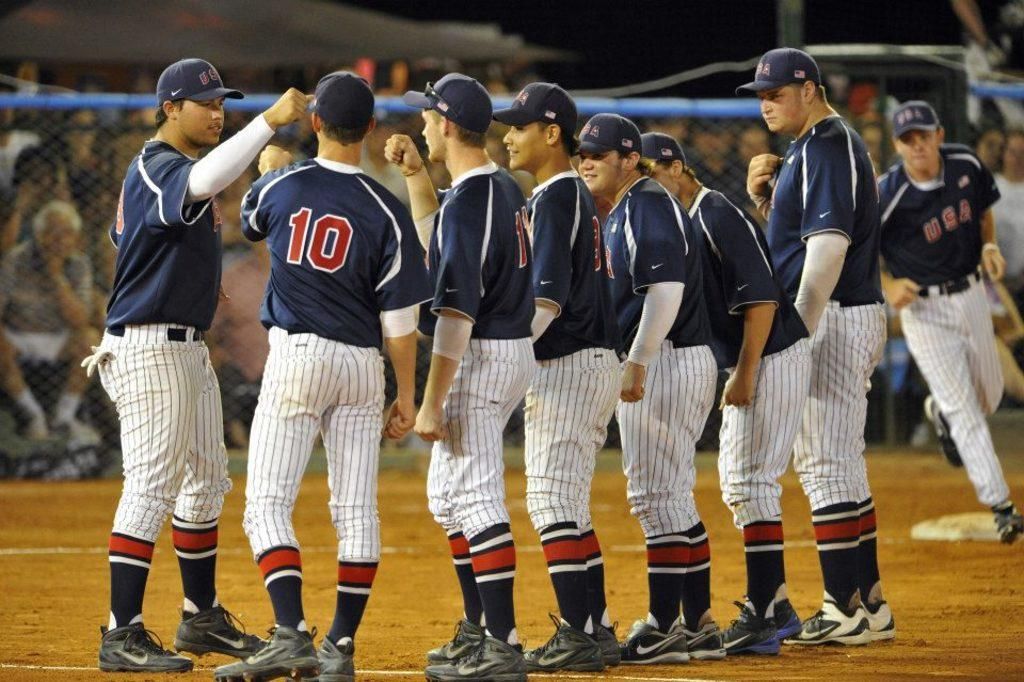<image>
Create a compact narrative representing the image presented. a group of players with one wearing the number 10 on it 